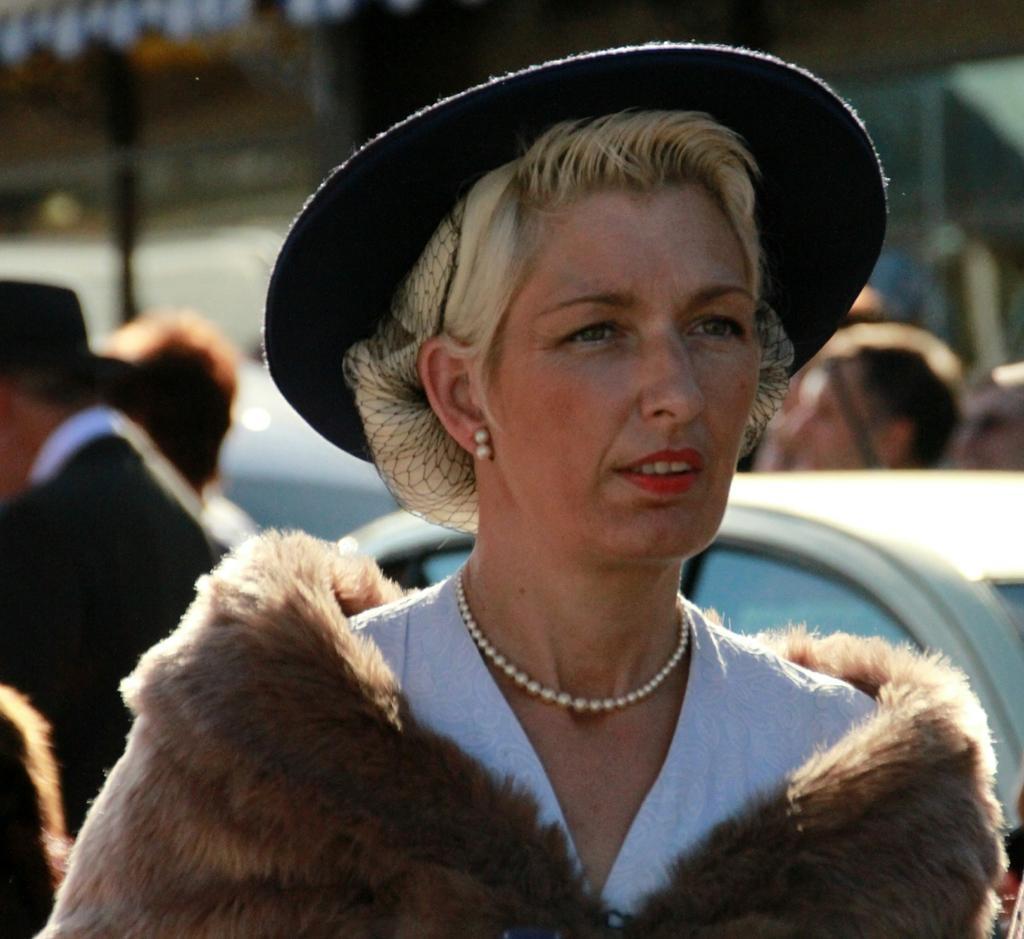How would you summarize this image in a sentence or two? In this image I can see the person with white and brown color dress and also hat. In the back I can see few people with different color dresses and the vehicle. And I can see the blurred background. 